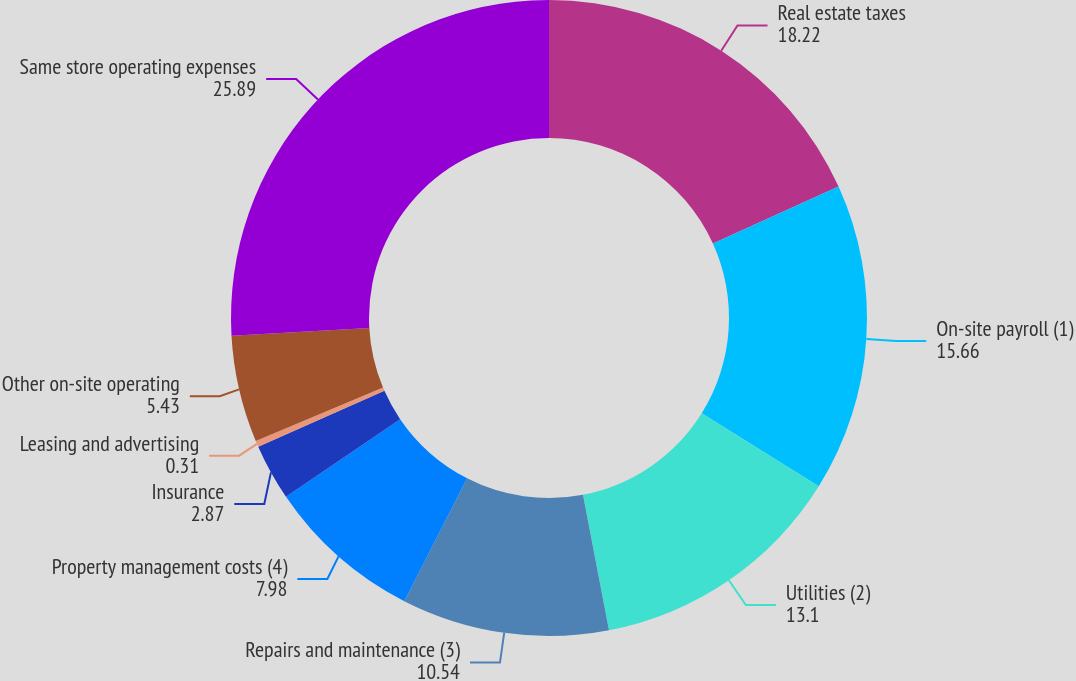Convert chart. <chart><loc_0><loc_0><loc_500><loc_500><pie_chart><fcel>Real estate taxes<fcel>On-site payroll (1)<fcel>Utilities (2)<fcel>Repairs and maintenance (3)<fcel>Property management costs (4)<fcel>Insurance<fcel>Leasing and advertising<fcel>Other on-site operating<fcel>Same store operating expenses<nl><fcel>18.22%<fcel>15.66%<fcel>13.1%<fcel>10.54%<fcel>7.98%<fcel>2.87%<fcel>0.31%<fcel>5.43%<fcel>25.89%<nl></chart> 